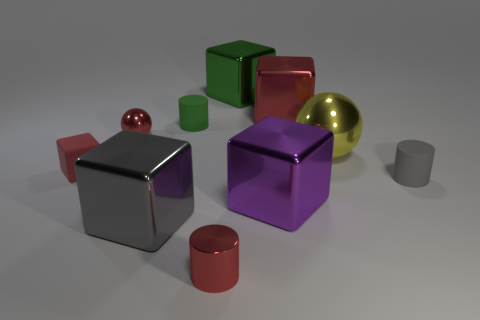What number of small red metallic balls are there?
Your response must be concise. 1. Does the red cylinder have the same size as the metal block that is left of the large green shiny thing?
Your answer should be very brief. No. There is a cylinder that is to the right of the green thing behind the green cylinder; what is its material?
Make the answer very short. Rubber. There is a matte object that is to the right of the red shiny object that is in front of the rubber cylinder to the right of the large green object; what is its size?
Offer a terse response. Small. Does the red rubber object have the same shape as the yellow metal object that is behind the gray block?
Offer a terse response. No. What is the green block made of?
Offer a very short reply. Metal. What number of shiny objects are tiny red things or purple blocks?
Your answer should be very brief. 3. Are there fewer red rubber cubes that are to the right of the green metallic cube than big gray blocks that are right of the small red cylinder?
Offer a terse response. No. Is there a large yellow thing that is on the right side of the tiny red metallic object that is behind the tiny rubber cylinder that is in front of the green rubber cylinder?
Ensure brevity in your answer.  Yes. There is a cylinder that is the same color as the tiny ball; what is it made of?
Make the answer very short. Metal. 